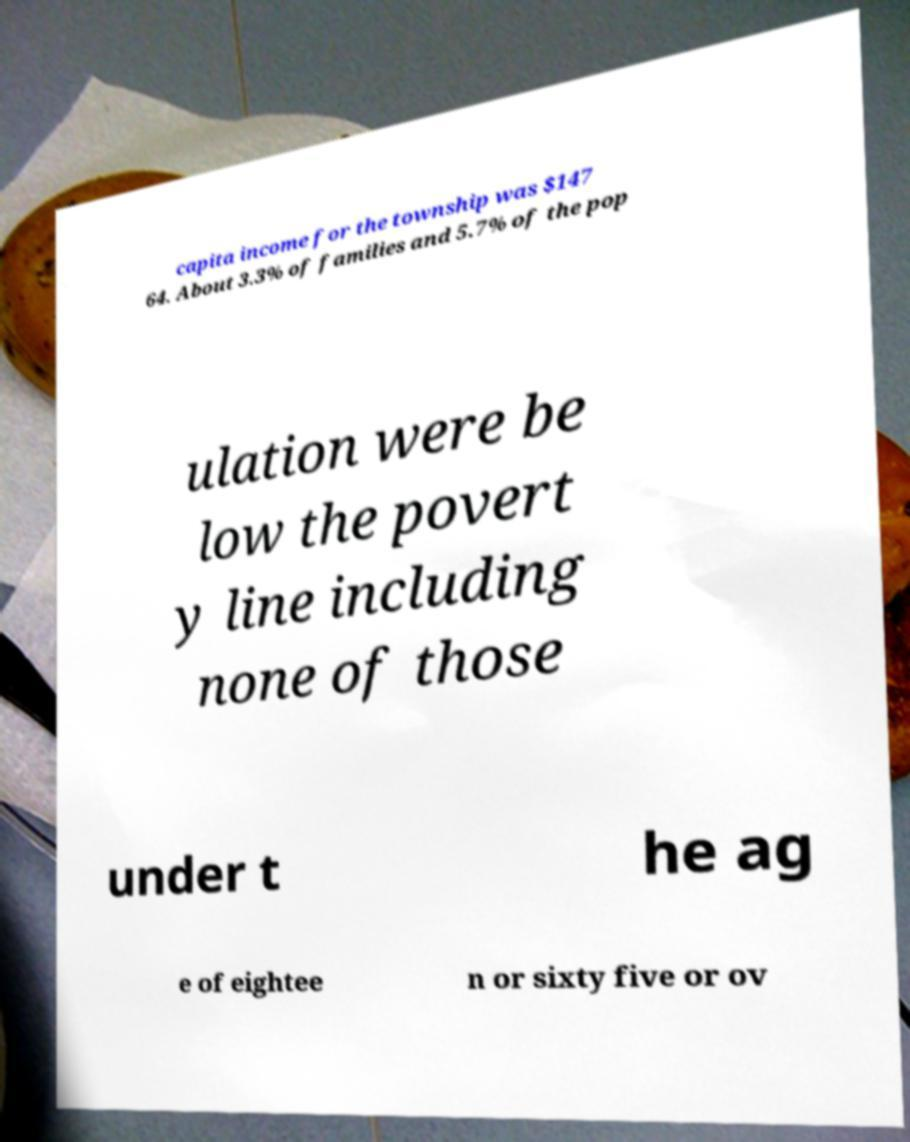For documentation purposes, I need the text within this image transcribed. Could you provide that? capita income for the township was $147 64. About 3.3% of families and 5.7% of the pop ulation were be low the povert y line including none of those under t he ag e of eightee n or sixty five or ov 